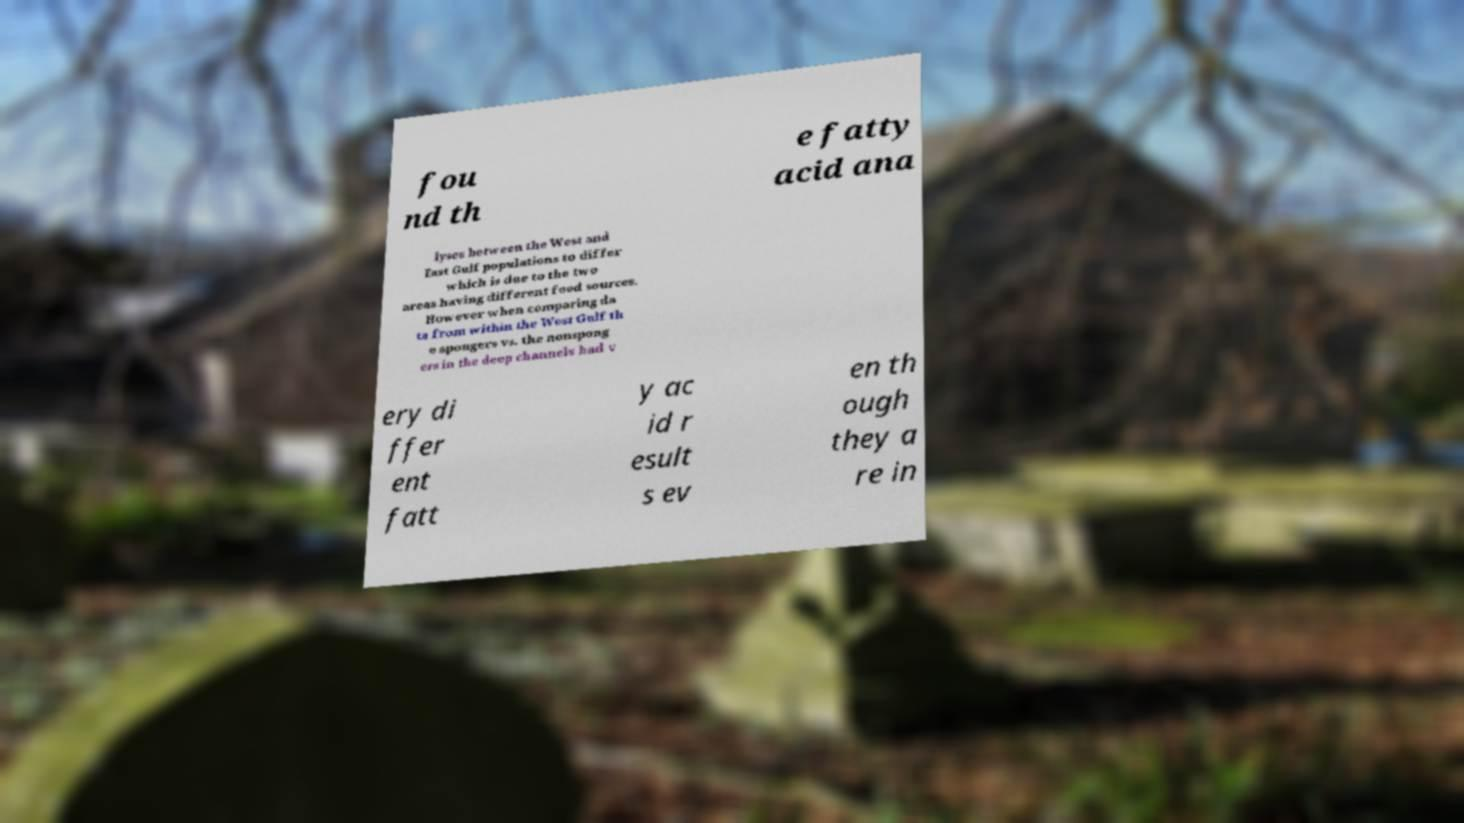There's text embedded in this image that I need extracted. Can you transcribe it verbatim? fou nd th e fatty acid ana lyses between the West and East Gulf populations to differ which is due to the two areas having different food sources. However when comparing da ta from within the West Gulf th e spongers vs. the nonspong ers in the deep channels had v ery di ffer ent fatt y ac id r esult s ev en th ough they a re in 